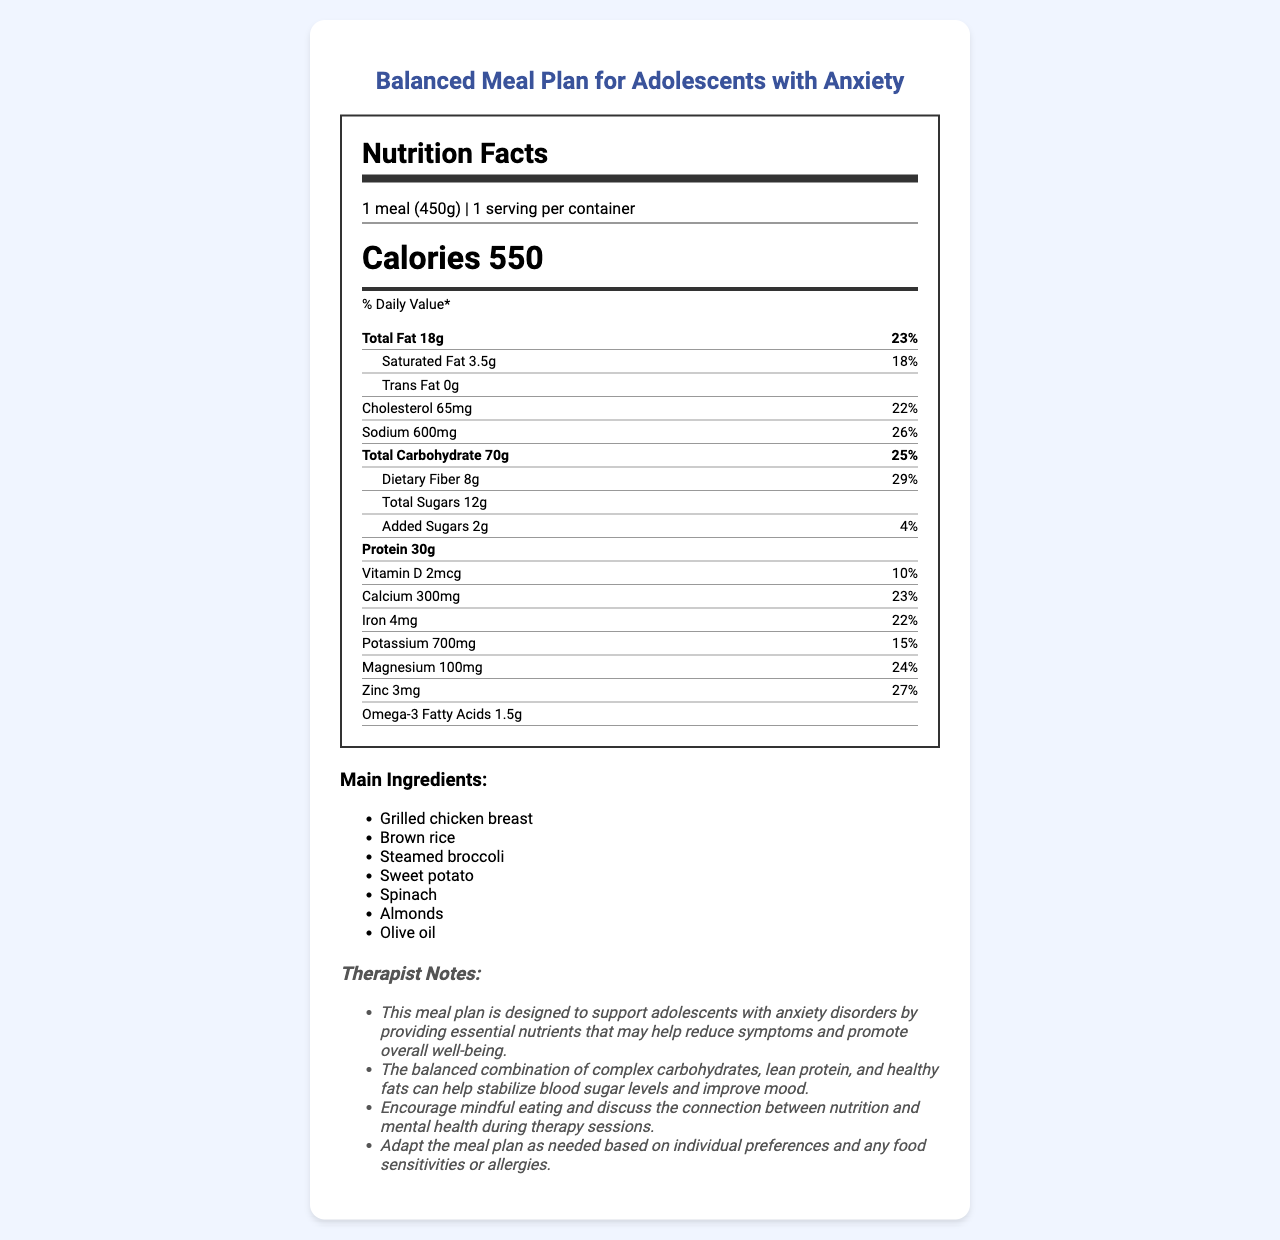what is the serving size of the meal? The serving size listed in the document is "1 meal (450g)".
Answer: 1 meal (450g) how many grams of protein does this meal provide? The nutrition label specifies that the meal contains 30g of protein.
Answer: 30g what percentage of the daily value of sodium does this meal contain? The sodium content is listed as providing 26% of the daily value.
Answer: 26% which ingredients in this meal are known to help reduce anxiety? The document lists "Magnesium," "Omega-3 fatty acids," "Complex carbohydrates," "Vitamin B6," and "Zinc" as anxiety-reducing nutrients.
Answer: Magnesium, Omega-3 fatty acids, Complex carbohydrates, Vitamin B6, Zinc what is the calorie content of the meal? The calorie content is specified as 550 calories.
Answer: 550 calories what are the main ingredients in this meal? The main ingredients are listed as "Grilled chicken breast," "Brown rice," "Steamed broccoli," "Sweet potato," "Spinach," "Almonds," "Olive oil".
Answer: Grilled chicken breast, Brown rice, Steamed broccoli, Sweet potato, Spinach, Almonds, Olive oil how much calcium does the meal provide? The nutrition label lists 300mg of calcium.
Answer: 300mg how many grams of dietary fiber are in the meal? The meal contains 8g of dietary fiber.
Answer: 8g how many grams of total carbohydrates are in this meal? The nutrition label indicates that there are 70g of total carbohydrates.
Answer: 70g does this meal contain probiotics? The additional information section states that the meal does not contain probiotics.
Answer: No what are the potential mental health benefits of this meal plan, as noted by the therapist? The therapist notes explain that the meal plan is designed to support adolescents with anxiety by providing essential nutrients, stabilizing blood sugar levels, and improving mood.
Answer: The meal plan provides essential nutrients that may help reduce anxiety symptoms and promote overall well-being. The balanced combination of complex carbohydrates, lean protein, and healthy fats can help stabilize blood sugar levels and improve mood. what percentage of the daily value of magnesium does this meal provide? A. 15% B. 20% C. 24% D. 30% The nutrition label lists the daily value percentage for magnesium as 24%.
Answer: C. 24% which of the following is not a main ingredient in this meal? 1. Brown rice 2. Steamed broccoli 3. Tofu 4. Sweet potato Tofu is not listed as a main ingredient in the document.
Answer: 3. Tofu does the meal have a high glycemic index? The additional info states that the meal has a low glycemic index.
Answer: No does this meal contain trans fat? The nutrition label indicates that the meal contains 0g of trans fat.
Answer: No what is the meal's relevance to mental health and anxiety? The summary captures the main idea of the document, summarizing the therapeutic benefits of the meal plan, nutrient content, and the emphasis on mindful eating.
Answer: This meal plan is designed to support adolescents with anxiety disorders by providing essential nutrients that may help reduce symptoms and promote overall well-being. It encourages mindful eating and a connection between nutrition and mental health, helping to stabilize blood sugar levels and improve mood. what is the recommended daily intake of potassium for adolescents? The document does not provide information on the recommended daily intake of potassium for adolescents.
Answer: Not enough information 